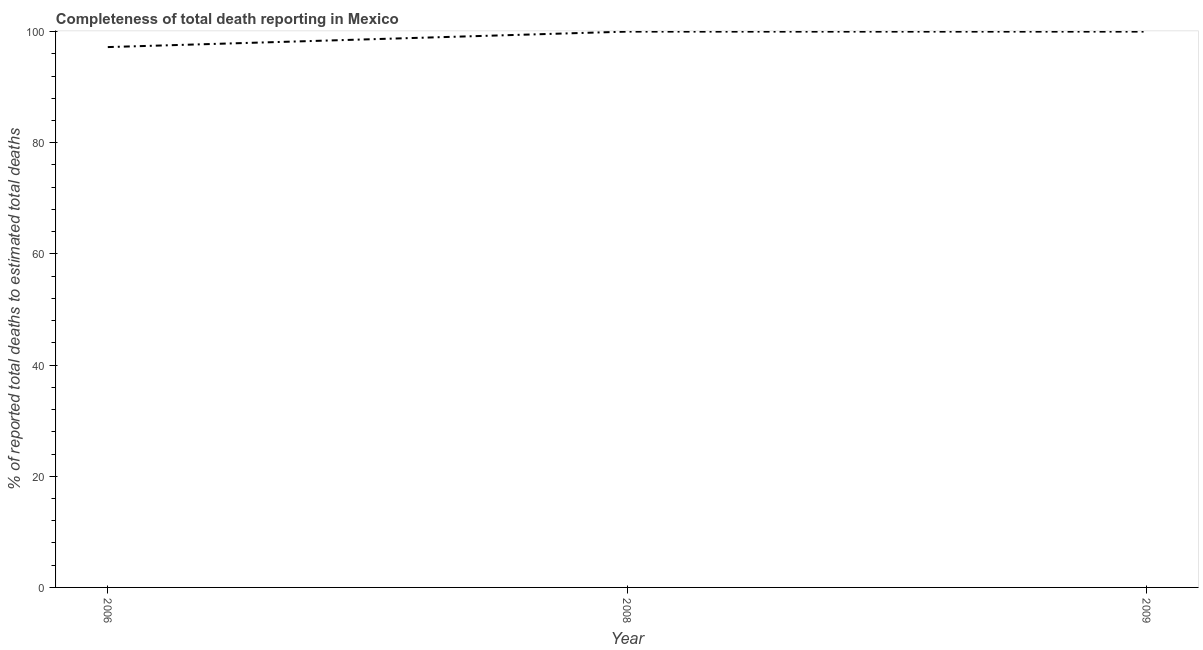What is the completeness of total death reports in 2008?
Give a very brief answer. 100. Across all years, what is the maximum completeness of total death reports?
Offer a very short reply. 100. Across all years, what is the minimum completeness of total death reports?
Ensure brevity in your answer.  97.21. What is the sum of the completeness of total death reports?
Provide a short and direct response. 297.21. What is the difference between the completeness of total death reports in 2008 and 2009?
Make the answer very short. 0. What is the average completeness of total death reports per year?
Your answer should be very brief. 99.07. Do a majority of the years between 2009 and 2006 (inclusive) have completeness of total death reports greater than 80 %?
Offer a terse response. No. What is the ratio of the completeness of total death reports in 2006 to that in 2009?
Your response must be concise. 0.97. Is the completeness of total death reports in 2006 less than that in 2009?
Keep it short and to the point. Yes. Is the difference between the completeness of total death reports in 2008 and 2009 greater than the difference between any two years?
Ensure brevity in your answer.  No. What is the difference between the highest and the second highest completeness of total death reports?
Your answer should be compact. 0. Is the sum of the completeness of total death reports in 2006 and 2008 greater than the maximum completeness of total death reports across all years?
Make the answer very short. Yes. What is the difference between the highest and the lowest completeness of total death reports?
Your answer should be very brief. 2.79. In how many years, is the completeness of total death reports greater than the average completeness of total death reports taken over all years?
Your answer should be very brief. 2. Does the completeness of total death reports monotonically increase over the years?
Provide a short and direct response. No. How many lines are there?
Your response must be concise. 1. Are the values on the major ticks of Y-axis written in scientific E-notation?
Ensure brevity in your answer.  No. Does the graph contain any zero values?
Keep it short and to the point. No. Does the graph contain grids?
Give a very brief answer. No. What is the title of the graph?
Your answer should be very brief. Completeness of total death reporting in Mexico. What is the label or title of the X-axis?
Your response must be concise. Year. What is the label or title of the Y-axis?
Give a very brief answer. % of reported total deaths to estimated total deaths. What is the % of reported total deaths to estimated total deaths of 2006?
Make the answer very short. 97.21. What is the difference between the % of reported total deaths to estimated total deaths in 2006 and 2008?
Your response must be concise. -2.79. What is the difference between the % of reported total deaths to estimated total deaths in 2006 and 2009?
Your answer should be very brief. -2.79. What is the difference between the % of reported total deaths to estimated total deaths in 2008 and 2009?
Your answer should be compact. 0. What is the ratio of the % of reported total deaths to estimated total deaths in 2006 to that in 2008?
Provide a short and direct response. 0.97. 